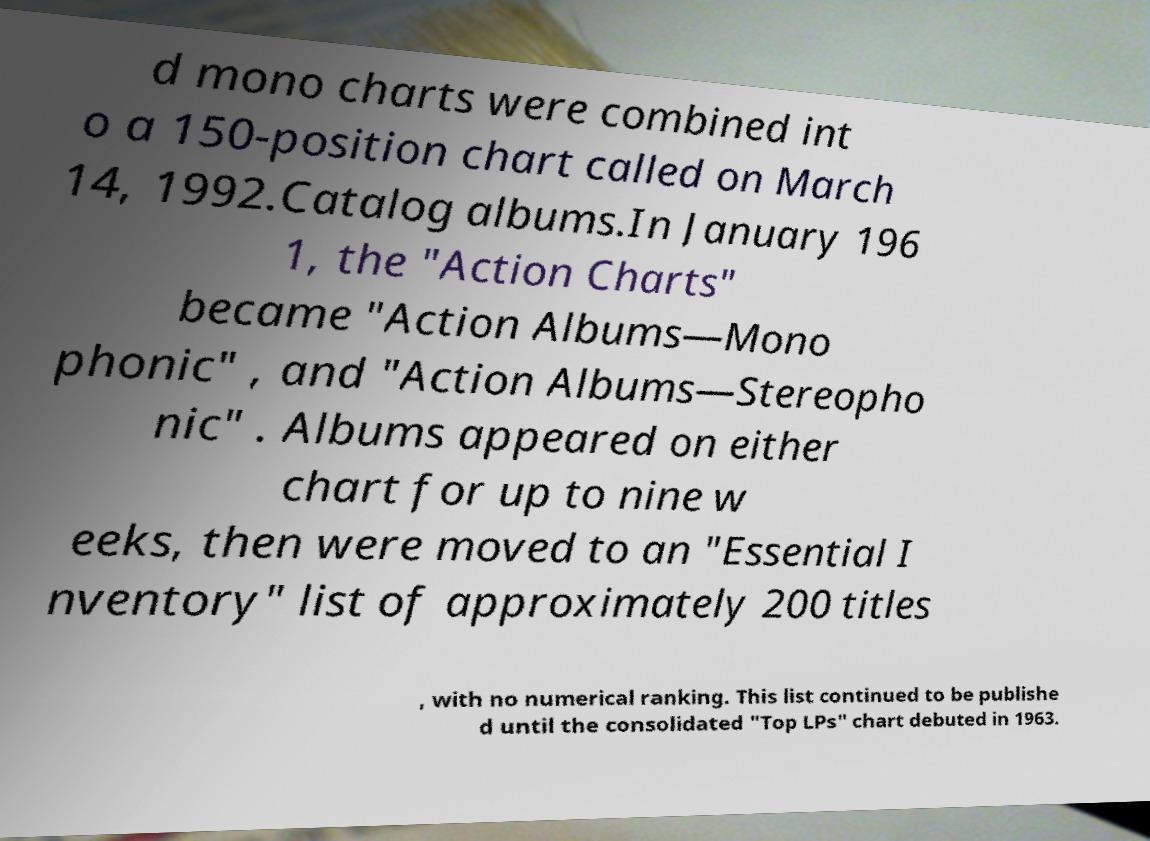Can you accurately transcribe the text from the provided image for me? d mono charts were combined int o a 150-position chart called on March 14, 1992.Catalog albums.In January 196 1, the "Action Charts" became "Action Albums—Mono phonic" , and "Action Albums—Stereopho nic" . Albums appeared on either chart for up to nine w eeks, then were moved to an "Essential I nventory" list of approximately 200 titles , with no numerical ranking. This list continued to be publishe d until the consolidated "Top LPs" chart debuted in 1963. 